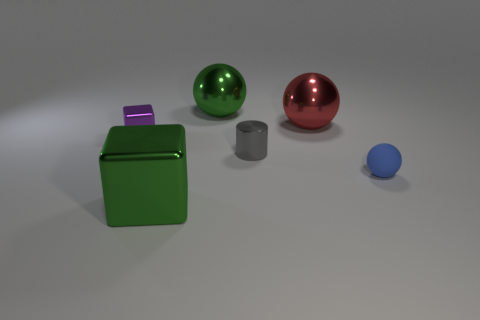Add 2 metal blocks. How many objects exist? 8 Subtract all cylinders. How many objects are left? 5 Add 3 big green spheres. How many big green spheres exist? 4 Subtract 0 cyan cylinders. How many objects are left? 6 Subtract all small metal spheres. Subtract all blocks. How many objects are left? 4 Add 6 red metallic balls. How many red metallic balls are left? 7 